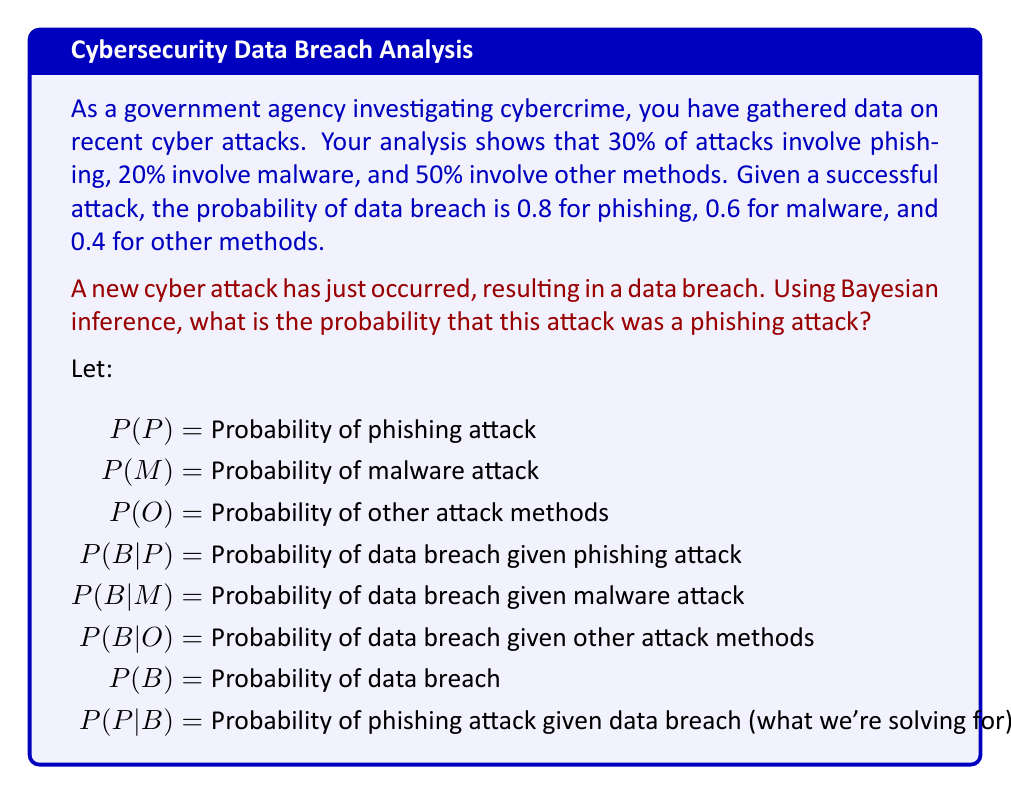Help me with this question. To solve this problem, we'll use Bayes' theorem:

$$P(P|B) = \frac{P(B|P) \cdot P(P)}{P(B)}$$

Step 1: Identify the given probabilities
$P(P) = 0.30$
$P(M) = 0.20$
$P(O) = 0.50$
$P(B|P) = 0.80$
$P(B|M) = 0.60$
$P(B|O) = 0.40$

Step 2: Calculate $P(B)$ using the law of total probability
$$P(B) = P(B|P) \cdot P(P) + P(B|M) \cdot P(M) + P(B|O) \cdot P(O)$$
$$P(B) = 0.80 \cdot 0.30 + 0.60 \cdot 0.20 + 0.40 \cdot 0.50$$
$$P(B) = 0.24 + 0.12 + 0.20 = 0.56$$

Step 3: Apply Bayes' theorem
$$P(P|B) = \frac{P(B|P) \cdot P(P)}{P(B)}$$
$$P(P|B) = \frac{0.80 \cdot 0.30}{0.56}$$
$$P(P|B) = \frac{0.24}{0.56} \approx 0.4286$$

Therefore, the probability that the attack was a phishing attack, given that a data breach occurred, is approximately 0.4286 or 42.86%.
Answer: 0.4286 (or 42.86%) 